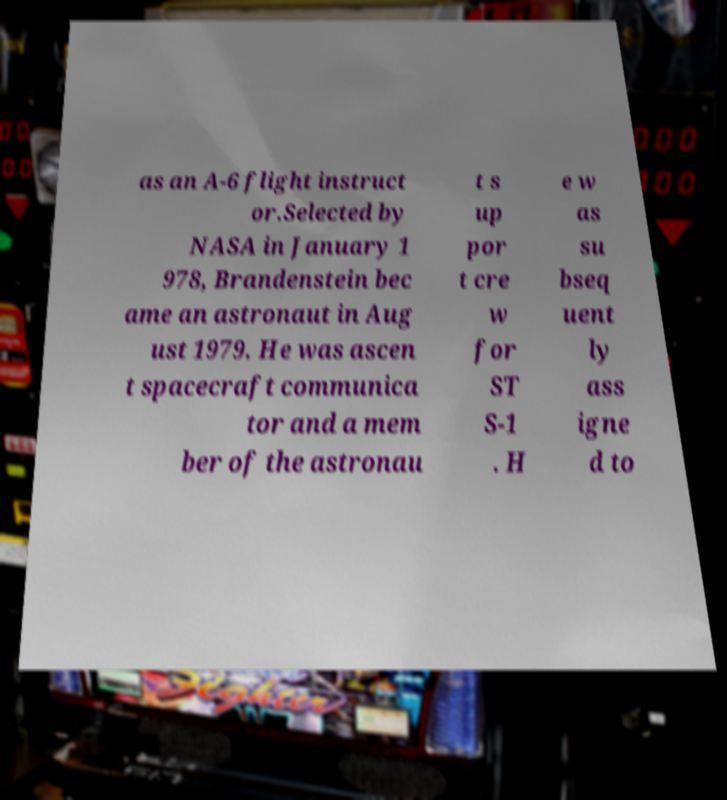For documentation purposes, I need the text within this image transcribed. Could you provide that? as an A-6 flight instruct or.Selected by NASA in January 1 978, Brandenstein bec ame an astronaut in Aug ust 1979. He was ascen t spacecraft communica tor and a mem ber of the astronau t s up por t cre w for ST S-1 . H e w as su bseq uent ly ass igne d to 